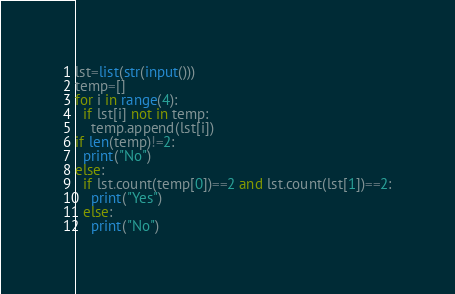Convert code to text. <code><loc_0><loc_0><loc_500><loc_500><_Python_>lst=list(str(input()))
temp=[]
for i in range(4):
  if lst[i] not in temp:
    temp.append(lst[i])
if len(temp)!=2:
  print("No")
else:
  if lst.count(temp[0])==2 and lst.count(lst[1])==2:
    print("Yes")
  else:
    print("No")</code> 